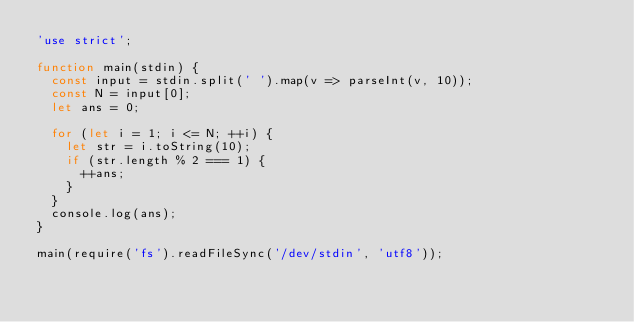<code> <loc_0><loc_0><loc_500><loc_500><_JavaScript_>'use strict';

function main(stdin) {
  const input = stdin.split(' ').map(v => parseInt(v, 10));
  const N = input[0];
  let ans = 0;

  for (let i = 1; i <= N; ++i) {
    let str = i.toString(10);
    if (str.length % 2 === 1) {
      ++ans;
    }
  }
  console.log(ans);
}

main(require('fs').readFileSync('/dev/stdin', 'utf8'));</code> 